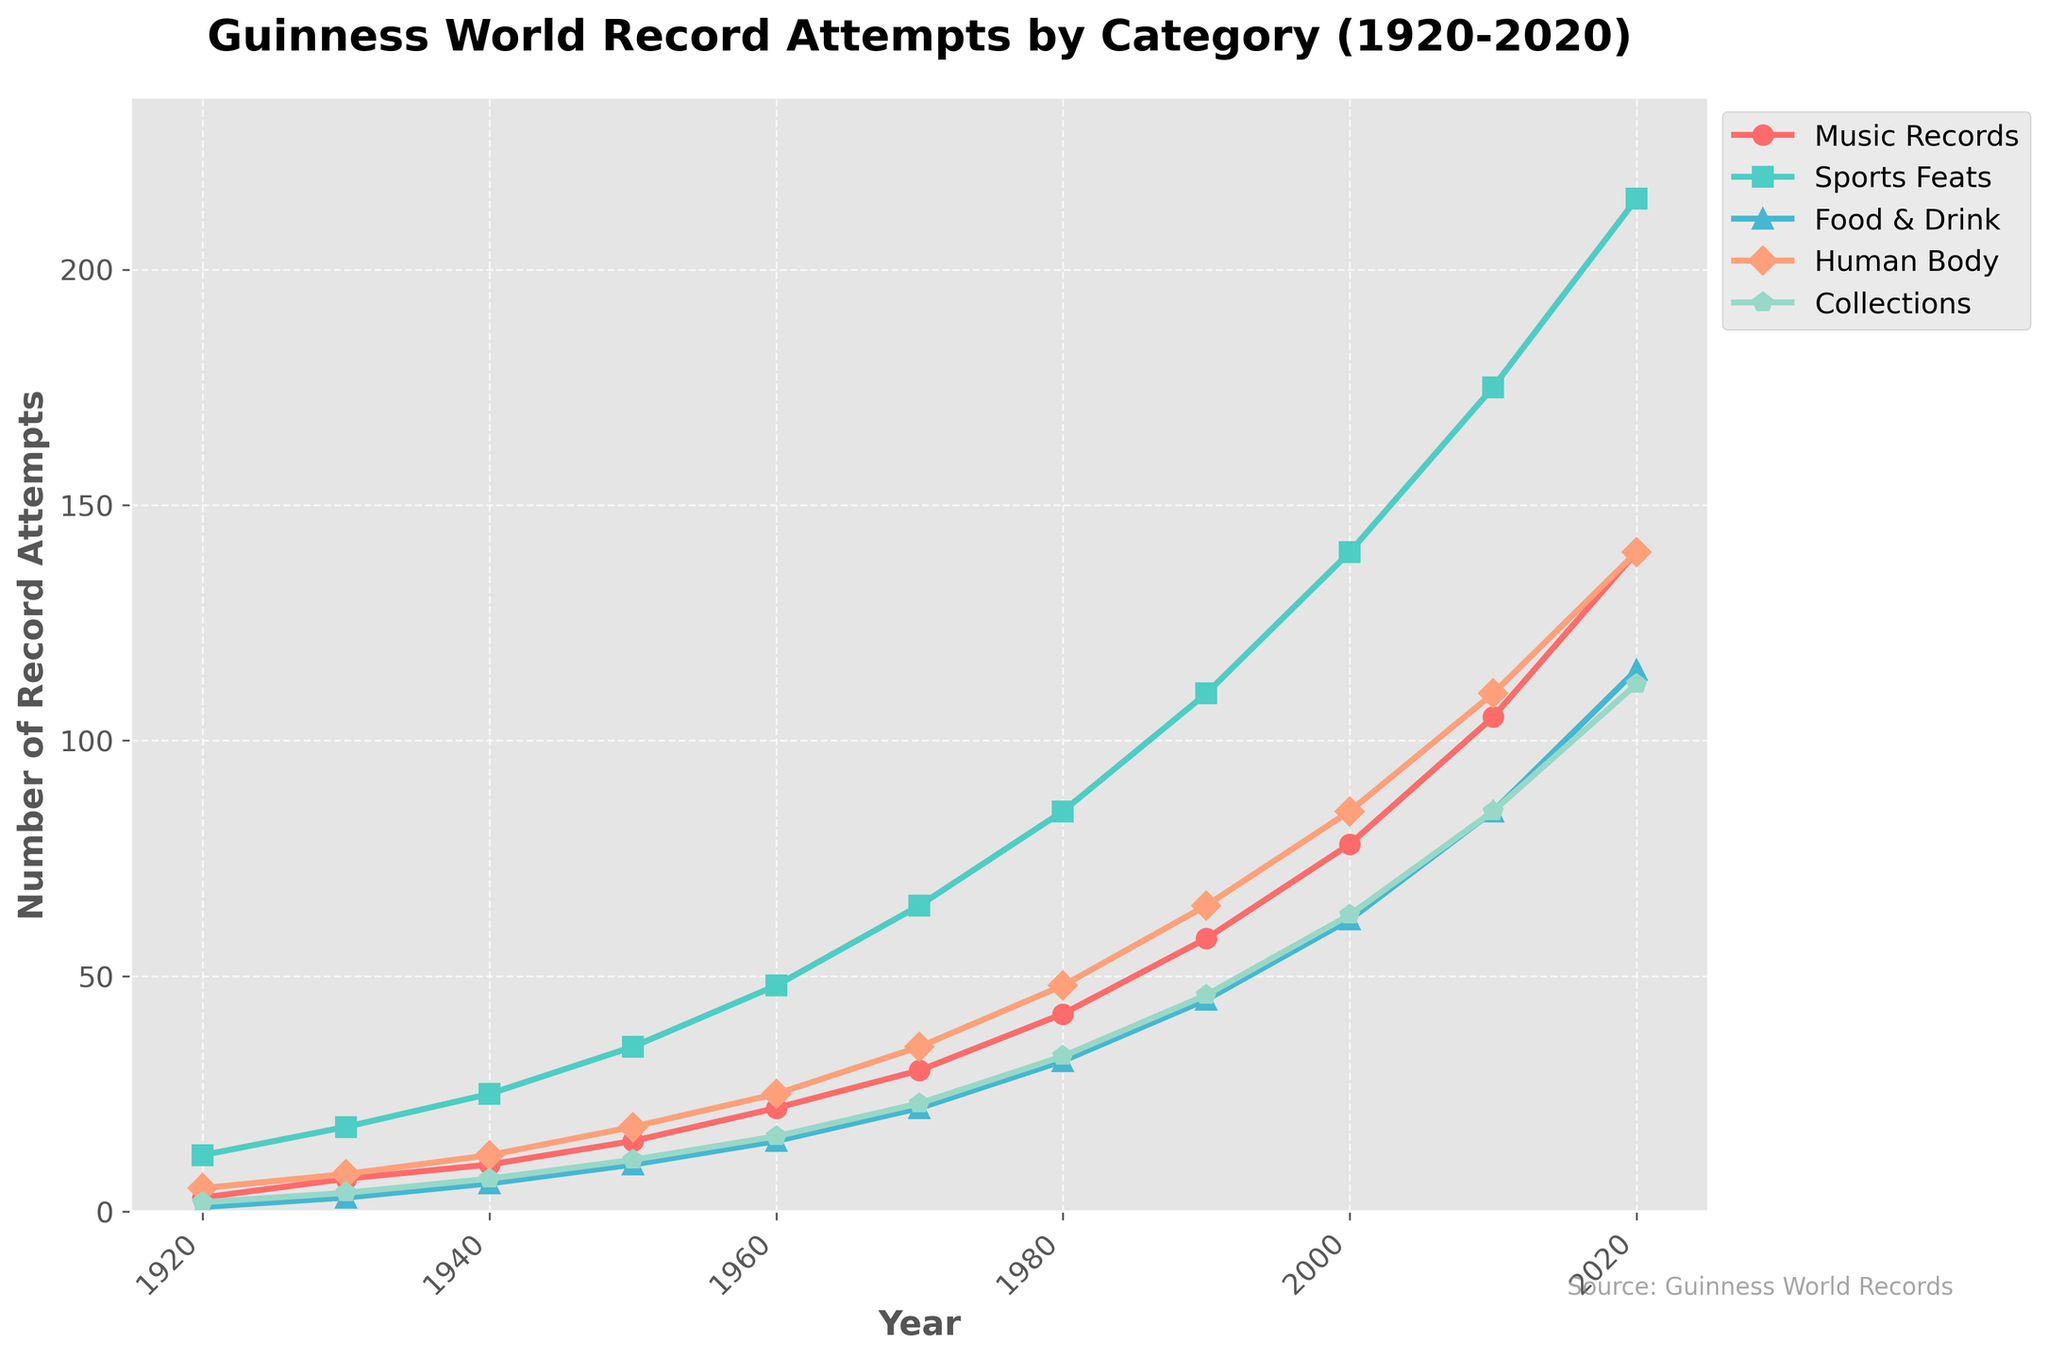What is the total number of Guinness World Record attempts in 2020? To find the total number of record attempts in 2020, sum the values across all categories for the year 2020. This gives us 140 (Music Records) + 215 (Sports Feats) + 115 (Food & Drink) + 140 (Human Body) + 112 (Collections) = 722.
Answer: 722 Which category saw the largest increase in record attempts from 1920 to 2020? By comparing the number of attempts in 1920 and 2020 for each category, we see the largest increase in "Sports Feats" (from 12 in 1920 to 215 in 2020).
Answer: Sports Feats How did the number of attempts in the "Collections" category change between 1940 and 1960? The number of attempts in the "Collections" category increased from 7 in 1940 to 16 in 1960.
Answer: Increased by 9 Is the number of "Human Body" record attempts in 1980 closer to that in 1970 or 1990? In 1980, the number of attempts was 48. In 1970, it was 35, and in 1990, it was 65. The difference between 35 and 48 is 13, while the difference between 48 and 65 is 17, making it closer to 1970.
Answer: 1970 Which two categories had the most similar number of attempts in 1940? In 1940, "Music Records" had 10, and "Collections" had 7. Similarly, "Human Body" had 12 and "Food & Drink" had 6. The smallest difference is between "Human Body" and "Music Records" (2).
Answer: Music Records and Human Body During which decade did the "Music Records" category see the most significant increase in record attempts? To determine the decade with the most significant increase, calculate the differences every decade. The largest increase for "Music Records" is from 2010 to 2020, with an increase of 35 (from 105 to 140).
Answer: 2010 to 2020 By how much did the total number of Guinness World Record attempts increase from 1930 to 1980? Sum the total attempts for each category in 1930 and 1980, then find the difference. In 1930, the total was 7+18+3+8+4=40. In 1980, it was 42+85+32+48+33=240. The increase is 240 - 40 = 200.
Answer: 200 Which category had the fewest attempts in 1960, and how many were there? By checking the figures for 1960, the "Food & Drink" category had the fewest attempts with 15 attempts.
Answer: Food & Drink, 15 